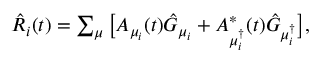Convert formula to latex. <formula><loc_0><loc_0><loc_500><loc_500>\begin{array} { r } { \hat { R } _ { i } ( t ) = \sum _ { \mu } \left [ A _ { \mu _ { i } } ( t ) \hat { G } _ { \mu _ { i } } + A _ { \mu _ { i } ^ { \dagger } } ^ { * } ( t ) \hat { G } _ { \mu _ { i } ^ { \dagger } } \right ] , } \end{array}</formula> 